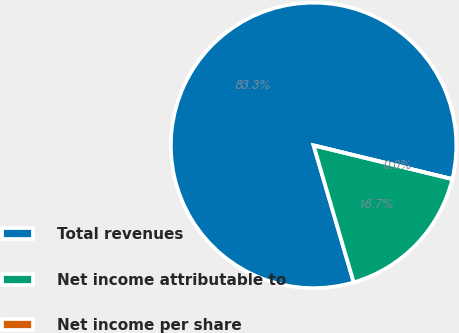Convert chart to OTSL. <chart><loc_0><loc_0><loc_500><loc_500><pie_chart><fcel>Total revenues<fcel>Net income attributable to<fcel>Net income per share<nl><fcel>83.33%<fcel>16.67%<fcel>0.0%<nl></chart> 